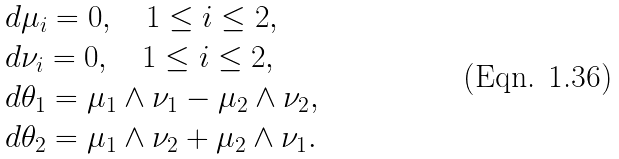Convert formula to latex. <formula><loc_0><loc_0><loc_500><loc_500>\begin{array} { l } d \mu _ { i } = 0 , \quad 1 \leq i \leq 2 , \\ d \nu _ { i } = 0 , \quad 1 \leq i \leq 2 , \\ d \theta _ { 1 } = \mu _ { 1 } \wedge \nu _ { 1 } - \mu _ { 2 } \wedge \nu _ { 2 } , \\ d \theta _ { 2 } = \mu _ { 1 } \wedge \nu _ { 2 } + \mu _ { 2 } \wedge \nu _ { 1 } . \end{array}</formula> 